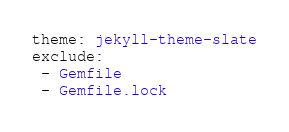Convert code to text. <code><loc_0><loc_0><loc_500><loc_500><_YAML_>theme: jekyll-theme-slate
exclude:
 - Gemfile
 - Gemfile.lock </code> 